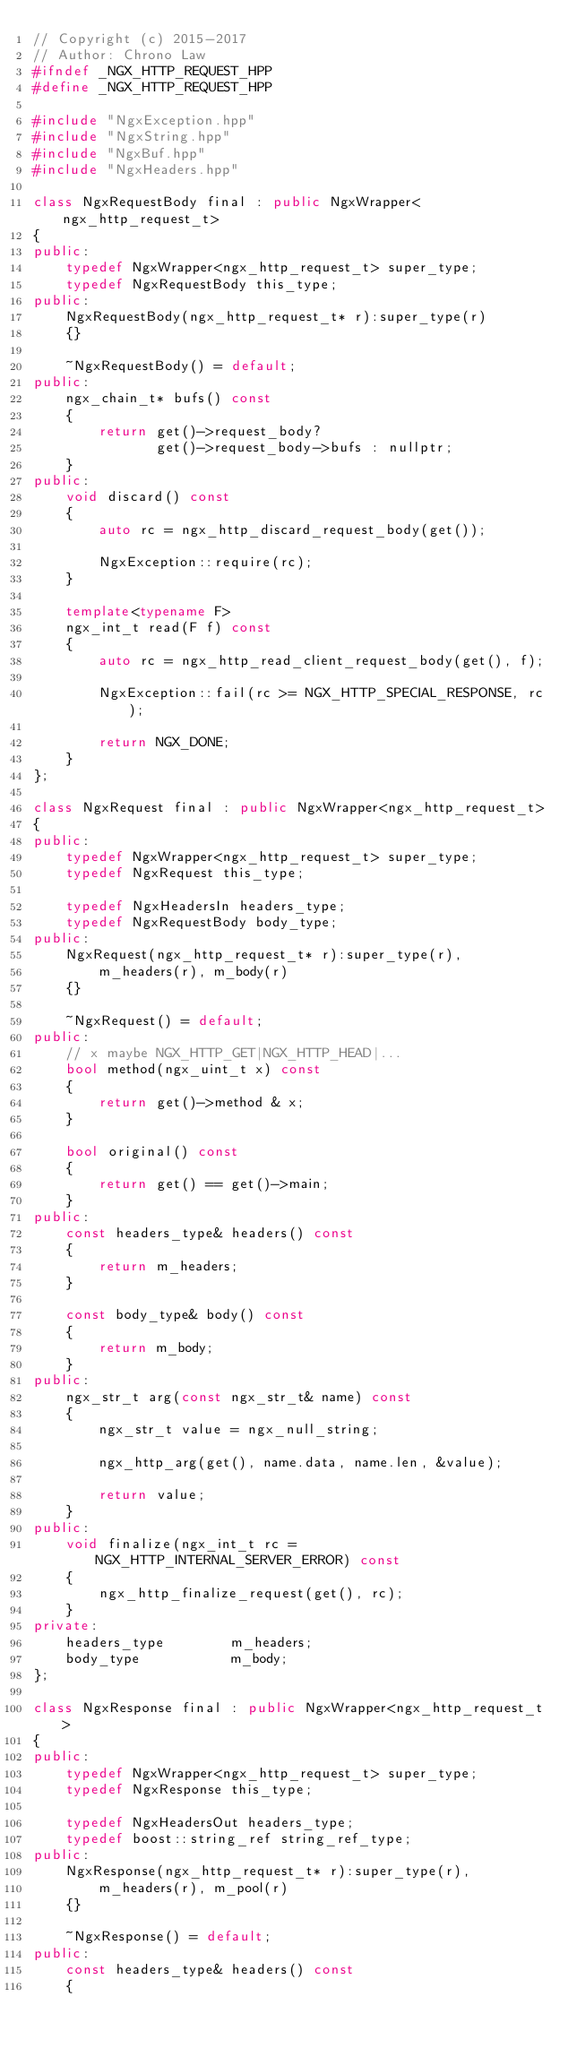<code> <loc_0><loc_0><loc_500><loc_500><_C++_>// Copyright (c) 2015-2017
// Author: Chrono Law
#ifndef _NGX_HTTP_REQUEST_HPP
#define _NGX_HTTP_REQUEST_HPP

#include "NgxException.hpp"
#include "NgxString.hpp"
#include "NgxBuf.hpp"
#include "NgxHeaders.hpp"

class NgxRequestBody final : public NgxWrapper<ngx_http_request_t>
{
public:
    typedef NgxWrapper<ngx_http_request_t> super_type;
    typedef NgxRequestBody this_type;
public:
    NgxRequestBody(ngx_http_request_t* r):super_type(r)
    {}

    ~NgxRequestBody() = default;
public:
    ngx_chain_t* bufs() const
    {
        return get()->request_body?
               get()->request_body->bufs : nullptr;
    }
public:
    void discard() const
    {
        auto rc = ngx_http_discard_request_body(get());

        NgxException::require(rc);
    }

    template<typename F>
    ngx_int_t read(F f) const
    {
        auto rc = ngx_http_read_client_request_body(get(), f);

        NgxException::fail(rc >= NGX_HTTP_SPECIAL_RESPONSE, rc);

        return NGX_DONE;
    }
};

class NgxRequest final : public NgxWrapper<ngx_http_request_t>
{
public:
    typedef NgxWrapper<ngx_http_request_t> super_type;
    typedef NgxRequest this_type;

    typedef NgxHeadersIn headers_type;
    typedef NgxRequestBody body_type;
public:
    NgxRequest(ngx_http_request_t* r):super_type(r),
        m_headers(r), m_body(r)
    {}

    ~NgxRequest() = default;
public:
    // x maybe NGX_HTTP_GET|NGX_HTTP_HEAD|...
    bool method(ngx_uint_t x) const
    {
        return get()->method & x;
    }

    bool original() const
    {
        return get() == get()->main;
    }
public:
    const headers_type& headers() const
    {
        return m_headers;
    }

    const body_type& body() const
    {
        return m_body;
    }
public:
    ngx_str_t arg(const ngx_str_t& name) const
    {
        ngx_str_t value = ngx_null_string;

        ngx_http_arg(get(), name.data, name.len, &value);

        return value;
    }
public:
    void finalize(ngx_int_t rc = NGX_HTTP_INTERNAL_SERVER_ERROR) const
    {
        ngx_http_finalize_request(get(), rc);
    }
private:
    headers_type        m_headers;
    body_type           m_body;
};

class NgxResponse final : public NgxWrapper<ngx_http_request_t>
{
public:
    typedef NgxWrapper<ngx_http_request_t> super_type;
    typedef NgxResponse this_type;

    typedef NgxHeadersOut headers_type;
    typedef boost::string_ref string_ref_type;
public:
    NgxResponse(ngx_http_request_t* r):super_type(r),
        m_headers(r), m_pool(r)
    {}

    ~NgxResponse() = default;
public:
    const headers_type& headers() const
    {</code> 